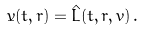<formula> <loc_0><loc_0><loc_500><loc_500>\dot { v } ( t , r ) = \hat { L } ( t , r , v ) \, .</formula> 